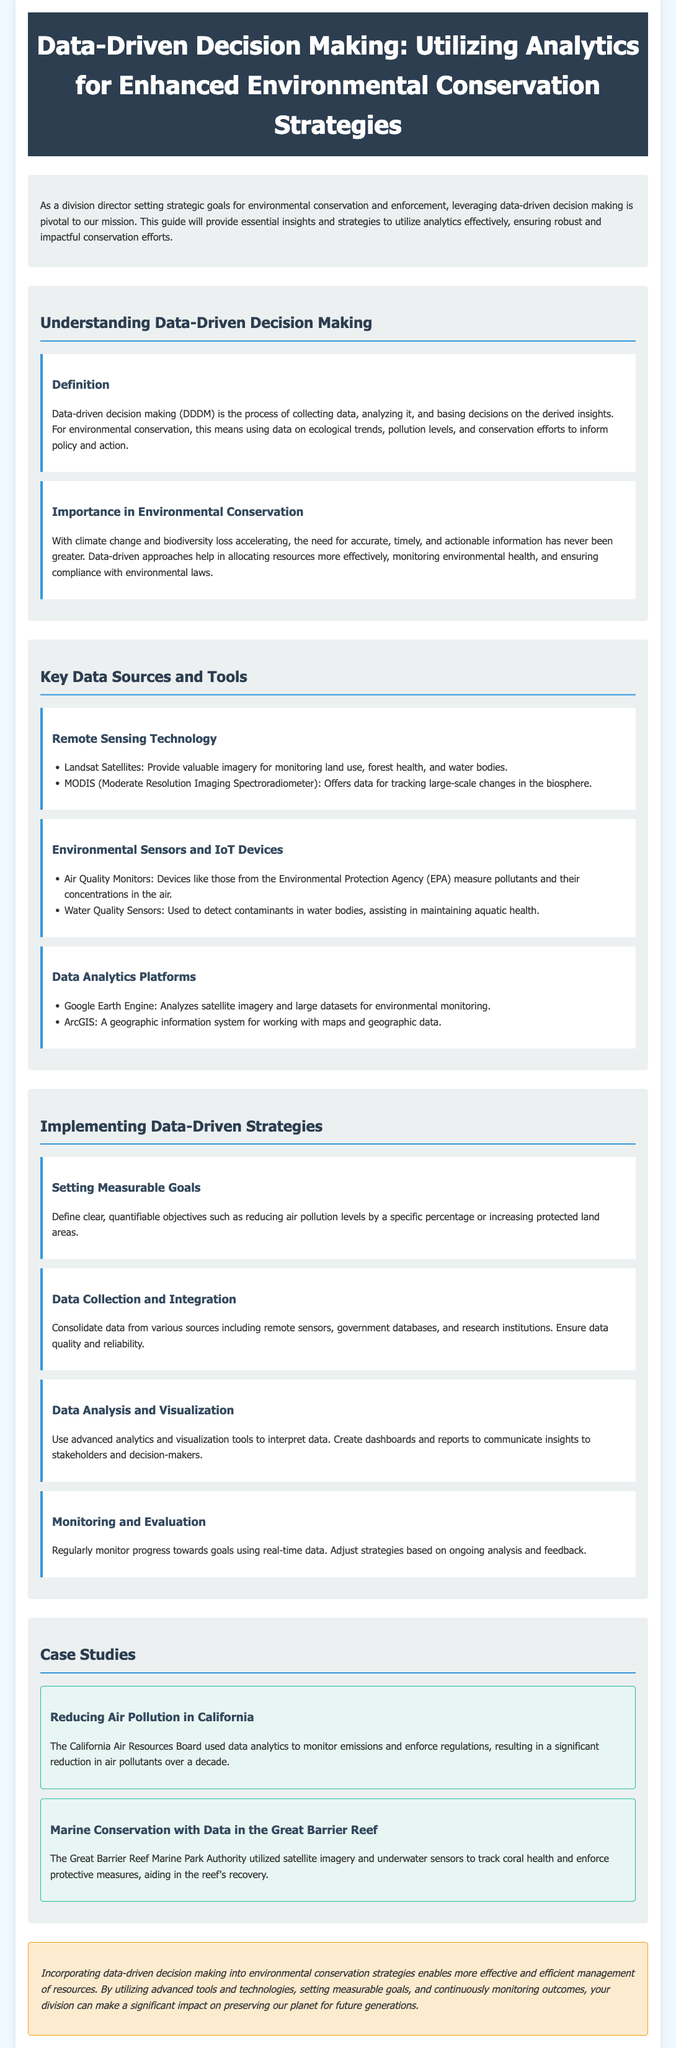what is the title of the document? The title is specified in the header of the document, providing the focus of the content.
Answer: Data-Driven Decision Making: Utilizing Analytics for Enhanced Environmental Conservation Strategies what is the definition of data-driven decision making? The definition is provided in the section describing DDDM, explaining its core aspects.
Answer: The process of collecting data, analyzing it, and basing decisions on the derived insights which technology is mentioned for tracking large-scale changes in the biosphere? The document lists MODIS as a tool for monitoring large-scale ecological changes.
Answer: MODIS (Moderate Resolution Imaging Spectroradiometer) what is one of the measurable goals suggested for data-driven strategies? The document outlines that measurable goals should be defined but provides an example to illustrate this.
Answer: Reducing air pollution levels by a specific percentage which organization is mentioned in relation to reducing air pollution in California? The document references a specific organization responsible for monitoring emissions in the case study.
Answer: California Air Resources Board what does the acronym IoT stand for? The document mentions IoT devices in the context of environmental sensors, necessitating inference of the acronym's meaning.
Answer: Internet of Things what are the two case studies highlighted in the document? The document specifically outlines two case studies demonstrating the impact of data-driven approaches.
Answer: Reducing Air Pollution in California and Marine Conservation with Data in the Great Barrier Reef how should strategies be adjusted according to the document? The document describes the necessity of adjusting strategies based on ongoing analysis and feedback.
Answer: Based on ongoing analysis and feedback what is one benefit of using data-driven decision making according to the document? The document emphasizes the advantages of implementing data-driven strategies, summarizing key benefits.
Answer: Enables more effective and efficient management of resources 